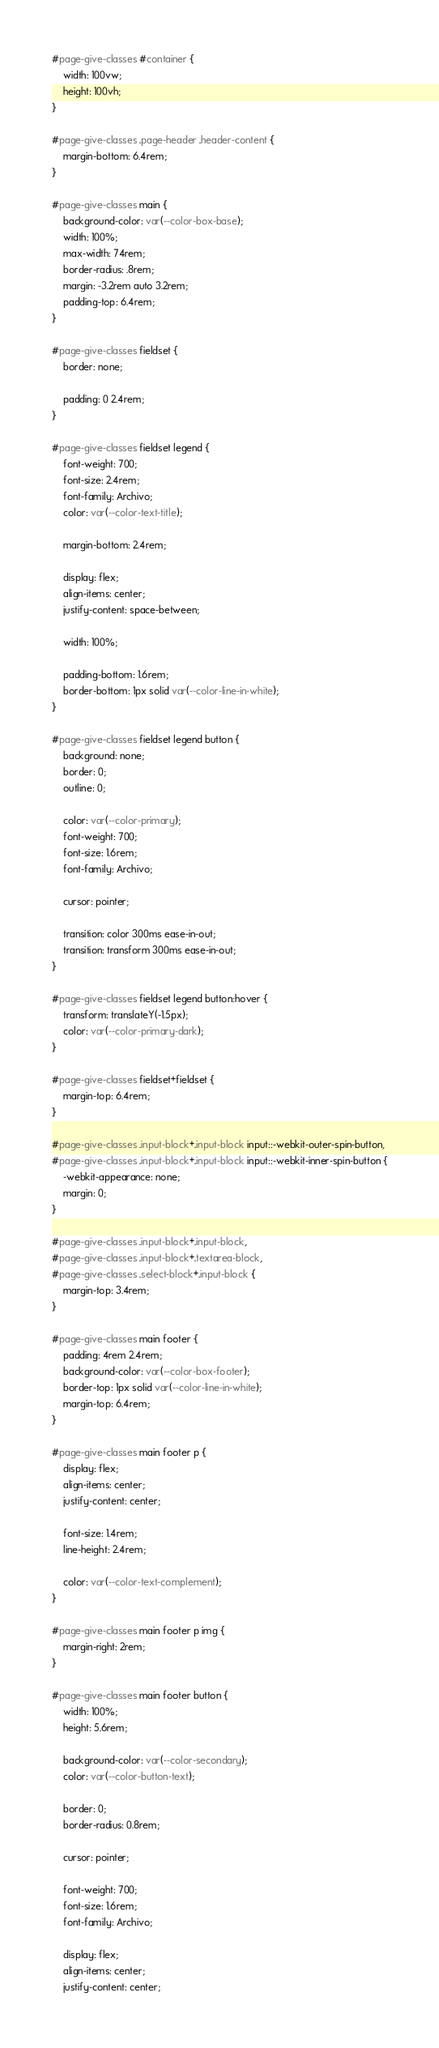<code> <loc_0><loc_0><loc_500><loc_500><_CSS_>#page-give-classes #container {
    width: 100vw;
    height: 100vh;
}

#page-give-classes .page-header .header-content {
    margin-bottom: 6.4rem;
}

#page-give-classes main {
    background-color: var(--color-box-base);
    width: 100%;
    max-width: 74rem;
    border-radius: .8rem;
    margin: -3.2rem auto 3.2rem;
    padding-top: 6.4rem;
}

#page-give-classes fieldset {
    border: none;

    padding: 0 2.4rem;
}

#page-give-classes fieldset legend {
    font-weight: 700;
    font-size: 2.4rem;
    font-family: Archivo;
    color: var(--color-text-title);

    margin-bottom: 2.4rem;

    display: flex;
    align-items: center;
    justify-content: space-between;

    width: 100%;

    padding-bottom: 1.6rem;
    border-bottom: 1px solid var(--color-line-in-white);
}

#page-give-classes fieldset legend button {
    background: none;
    border: 0;
    outline: 0;

    color: var(--color-primary);
    font-weight: 700;
    font-size: 1.6rem;
    font-family: Archivo;

    cursor: pointer;

    transition: color 300ms ease-in-out;
    transition: transform 300ms ease-in-out;
}

#page-give-classes fieldset legend button:hover {
    transform: translateY(-1.5px);
    color: var(--color-primary-dark);
}

#page-give-classes fieldset+fieldset {
    margin-top: 6.4rem;
}

#page-give-classes .input-block+.input-block input::-webkit-outer-spin-button,
#page-give-classes .input-block+.input-block input::-webkit-inner-spin-button {
    -webkit-appearance: none;
    margin: 0;
}

#page-give-classes .input-block+.input-block,
#page-give-classes .input-block+.textarea-block,
#page-give-classes .select-block+.input-block {
    margin-top: 3.4rem;
}

#page-give-classes main footer {
    padding: 4rem 2.4rem;
    background-color: var(--color-box-footer);
    border-top: 1px solid var(--color-line-in-white);
    margin-top: 6.4rem;
}

#page-give-classes main footer p {
    display: flex;
    align-items: center;
    justify-content: center;

    font-size: 1.4rem;
    line-height: 2.4rem;

    color: var(--color-text-complement);
}

#page-give-classes main footer p img {
    margin-right: 2rem;
}

#page-give-classes main footer button {
    width: 100%;
    height: 5.6rem;

    background-color: var(--color-secondary);
    color: var(--color-button-text);

    border: 0;
    border-radius: 0.8rem;

    cursor: pointer;

    font-weight: 700;
    font-size: 1.6rem;
    font-family: Archivo;

    display: flex;
    align-items: center;
    justify-content: center;
</code> 